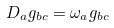Convert formula to latex. <formula><loc_0><loc_0><loc_500><loc_500>D _ { a } g _ { b c } = \omega _ { a } g _ { b c }</formula> 